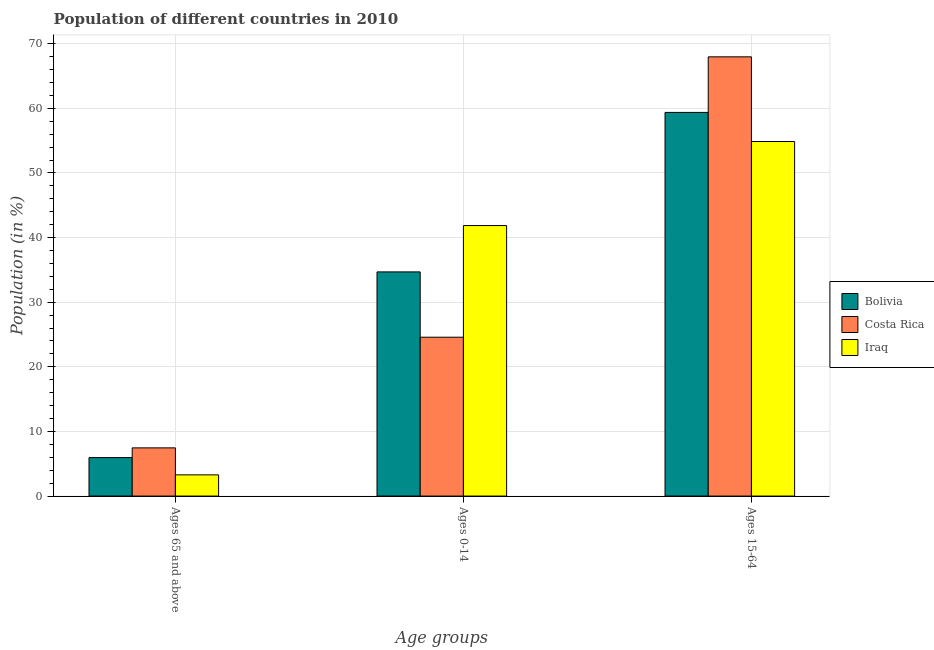How many different coloured bars are there?
Provide a succinct answer. 3. Are the number of bars per tick equal to the number of legend labels?
Your response must be concise. Yes. Are the number of bars on each tick of the X-axis equal?
Your answer should be very brief. Yes. How many bars are there on the 3rd tick from the right?
Provide a succinct answer. 3. What is the label of the 2nd group of bars from the left?
Keep it short and to the point. Ages 0-14. What is the percentage of population within the age-group 0-14 in Iraq?
Your answer should be very brief. 41.86. Across all countries, what is the maximum percentage of population within the age-group 0-14?
Ensure brevity in your answer.  41.86. Across all countries, what is the minimum percentage of population within the age-group 0-14?
Give a very brief answer. 24.58. In which country was the percentage of population within the age-group 15-64 maximum?
Offer a very short reply. Costa Rica. What is the total percentage of population within the age-group 15-64 in the graph?
Provide a succinct answer. 182.19. What is the difference between the percentage of population within the age-group of 65 and above in Iraq and that in Bolivia?
Give a very brief answer. -2.67. What is the difference between the percentage of population within the age-group of 65 and above in Costa Rica and the percentage of population within the age-group 15-64 in Iraq?
Your answer should be very brief. -47.4. What is the average percentage of population within the age-group 15-64 per country?
Make the answer very short. 60.73. What is the difference between the percentage of population within the age-group of 65 and above and percentage of population within the age-group 0-14 in Bolivia?
Ensure brevity in your answer.  -28.73. In how many countries, is the percentage of population within the age-group 0-14 greater than 42 %?
Provide a succinct answer. 0. What is the ratio of the percentage of population within the age-group of 65 and above in Iraq to that in Bolivia?
Your answer should be compact. 0.55. Is the percentage of population within the age-group 0-14 in Bolivia less than that in Iraq?
Your answer should be very brief. Yes. Is the difference between the percentage of population within the age-group of 65 and above in Bolivia and Costa Rica greater than the difference between the percentage of population within the age-group 15-64 in Bolivia and Costa Rica?
Offer a terse response. Yes. What is the difference between the highest and the second highest percentage of population within the age-group of 65 and above?
Give a very brief answer. 1.51. What is the difference between the highest and the lowest percentage of population within the age-group 15-64?
Your answer should be compact. 13.1. In how many countries, is the percentage of population within the age-group 15-64 greater than the average percentage of population within the age-group 15-64 taken over all countries?
Offer a terse response. 1. What does the 2nd bar from the right in Ages 65 and above represents?
Give a very brief answer. Costa Rica. Are all the bars in the graph horizontal?
Your response must be concise. No. How many countries are there in the graph?
Offer a very short reply. 3. Does the graph contain any zero values?
Provide a short and direct response. No. Does the graph contain grids?
Your response must be concise. Yes. How many legend labels are there?
Give a very brief answer. 3. How are the legend labels stacked?
Offer a very short reply. Vertical. What is the title of the graph?
Your answer should be compact. Population of different countries in 2010. Does "Belgium" appear as one of the legend labels in the graph?
Ensure brevity in your answer.  No. What is the label or title of the X-axis?
Keep it short and to the point. Age groups. What is the Population (in %) of Bolivia in Ages 65 and above?
Your answer should be very brief. 5.95. What is the Population (in %) of Costa Rica in Ages 65 and above?
Make the answer very short. 7.46. What is the Population (in %) in Iraq in Ages 65 and above?
Give a very brief answer. 3.28. What is the Population (in %) of Bolivia in Ages 0-14?
Your response must be concise. 34.69. What is the Population (in %) of Costa Rica in Ages 0-14?
Keep it short and to the point. 24.58. What is the Population (in %) in Iraq in Ages 0-14?
Your answer should be compact. 41.86. What is the Population (in %) of Bolivia in Ages 15-64?
Provide a short and direct response. 59.36. What is the Population (in %) of Costa Rica in Ages 15-64?
Keep it short and to the point. 67.96. What is the Population (in %) in Iraq in Ages 15-64?
Make the answer very short. 54.86. Across all Age groups, what is the maximum Population (in %) in Bolivia?
Offer a terse response. 59.36. Across all Age groups, what is the maximum Population (in %) of Costa Rica?
Make the answer very short. 67.96. Across all Age groups, what is the maximum Population (in %) of Iraq?
Keep it short and to the point. 54.86. Across all Age groups, what is the minimum Population (in %) in Bolivia?
Offer a terse response. 5.95. Across all Age groups, what is the minimum Population (in %) in Costa Rica?
Provide a short and direct response. 7.46. Across all Age groups, what is the minimum Population (in %) in Iraq?
Your answer should be very brief. 3.28. What is the total Population (in %) in Iraq in the graph?
Your answer should be compact. 100. What is the difference between the Population (in %) in Bolivia in Ages 65 and above and that in Ages 0-14?
Offer a terse response. -28.73. What is the difference between the Population (in %) of Costa Rica in Ages 65 and above and that in Ages 0-14?
Your answer should be compact. -17.12. What is the difference between the Population (in %) of Iraq in Ages 65 and above and that in Ages 0-14?
Make the answer very short. -38.58. What is the difference between the Population (in %) of Bolivia in Ages 65 and above and that in Ages 15-64?
Make the answer very short. -53.41. What is the difference between the Population (in %) in Costa Rica in Ages 65 and above and that in Ages 15-64?
Give a very brief answer. -60.51. What is the difference between the Population (in %) in Iraq in Ages 65 and above and that in Ages 15-64?
Your answer should be very brief. -51.58. What is the difference between the Population (in %) of Bolivia in Ages 0-14 and that in Ages 15-64?
Your response must be concise. -24.68. What is the difference between the Population (in %) of Costa Rica in Ages 0-14 and that in Ages 15-64?
Provide a succinct answer. -43.38. What is the difference between the Population (in %) in Iraq in Ages 0-14 and that in Ages 15-64?
Provide a short and direct response. -13. What is the difference between the Population (in %) of Bolivia in Ages 65 and above and the Population (in %) of Costa Rica in Ages 0-14?
Ensure brevity in your answer.  -18.63. What is the difference between the Population (in %) of Bolivia in Ages 65 and above and the Population (in %) of Iraq in Ages 0-14?
Make the answer very short. -35.91. What is the difference between the Population (in %) in Costa Rica in Ages 65 and above and the Population (in %) in Iraq in Ages 0-14?
Your answer should be very brief. -34.4. What is the difference between the Population (in %) of Bolivia in Ages 65 and above and the Population (in %) of Costa Rica in Ages 15-64?
Offer a very short reply. -62.01. What is the difference between the Population (in %) of Bolivia in Ages 65 and above and the Population (in %) of Iraq in Ages 15-64?
Your answer should be compact. -48.91. What is the difference between the Population (in %) in Costa Rica in Ages 65 and above and the Population (in %) in Iraq in Ages 15-64?
Ensure brevity in your answer.  -47.4. What is the difference between the Population (in %) in Bolivia in Ages 0-14 and the Population (in %) in Costa Rica in Ages 15-64?
Your answer should be compact. -33.28. What is the difference between the Population (in %) in Bolivia in Ages 0-14 and the Population (in %) in Iraq in Ages 15-64?
Your answer should be compact. -20.18. What is the difference between the Population (in %) of Costa Rica in Ages 0-14 and the Population (in %) of Iraq in Ages 15-64?
Your answer should be compact. -30.28. What is the average Population (in %) in Bolivia per Age groups?
Keep it short and to the point. 33.33. What is the average Population (in %) of Costa Rica per Age groups?
Make the answer very short. 33.33. What is the average Population (in %) of Iraq per Age groups?
Keep it short and to the point. 33.33. What is the difference between the Population (in %) in Bolivia and Population (in %) in Costa Rica in Ages 65 and above?
Provide a succinct answer. -1.51. What is the difference between the Population (in %) in Bolivia and Population (in %) in Iraq in Ages 65 and above?
Your answer should be very brief. 2.67. What is the difference between the Population (in %) in Costa Rica and Population (in %) in Iraq in Ages 65 and above?
Give a very brief answer. 4.18. What is the difference between the Population (in %) in Bolivia and Population (in %) in Costa Rica in Ages 0-14?
Give a very brief answer. 10.11. What is the difference between the Population (in %) of Bolivia and Population (in %) of Iraq in Ages 0-14?
Your response must be concise. -7.17. What is the difference between the Population (in %) of Costa Rica and Population (in %) of Iraq in Ages 0-14?
Provide a short and direct response. -17.28. What is the difference between the Population (in %) in Bolivia and Population (in %) in Costa Rica in Ages 15-64?
Offer a very short reply. -8.6. What is the difference between the Population (in %) of Bolivia and Population (in %) of Iraq in Ages 15-64?
Provide a short and direct response. 4.5. What is the difference between the Population (in %) in Costa Rica and Population (in %) in Iraq in Ages 15-64?
Provide a short and direct response. 13.1. What is the ratio of the Population (in %) of Bolivia in Ages 65 and above to that in Ages 0-14?
Provide a succinct answer. 0.17. What is the ratio of the Population (in %) in Costa Rica in Ages 65 and above to that in Ages 0-14?
Give a very brief answer. 0.3. What is the ratio of the Population (in %) of Iraq in Ages 65 and above to that in Ages 0-14?
Ensure brevity in your answer.  0.08. What is the ratio of the Population (in %) in Bolivia in Ages 65 and above to that in Ages 15-64?
Your response must be concise. 0.1. What is the ratio of the Population (in %) in Costa Rica in Ages 65 and above to that in Ages 15-64?
Offer a very short reply. 0.11. What is the ratio of the Population (in %) in Iraq in Ages 65 and above to that in Ages 15-64?
Your answer should be very brief. 0.06. What is the ratio of the Population (in %) in Bolivia in Ages 0-14 to that in Ages 15-64?
Offer a very short reply. 0.58. What is the ratio of the Population (in %) in Costa Rica in Ages 0-14 to that in Ages 15-64?
Provide a short and direct response. 0.36. What is the ratio of the Population (in %) of Iraq in Ages 0-14 to that in Ages 15-64?
Your answer should be very brief. 0.76. What is the difference between the highest and the second highest Population (in %) of Bolivia?
Offer a terse response. 24.68. What is the difference between the highest and the second highest Population (in %) in Costa Rica?
Your answer should be very brief. 43.38. What is the difference between the highest and the second highest Population (in %) in Iraq?
Your response must be concise. 13. What is the difference between the highest and the lowest Population (in %) of Bolivia?
Your response must be concise. 53.41. What is the difference between the highest and the lowest Population (in %) of Costa Rica?
Offer a very short reply. 60.51. What is the difference between the highest and the lowest Population (in %) in Iraq?
Ensure brevity in your answer.  51.58. 